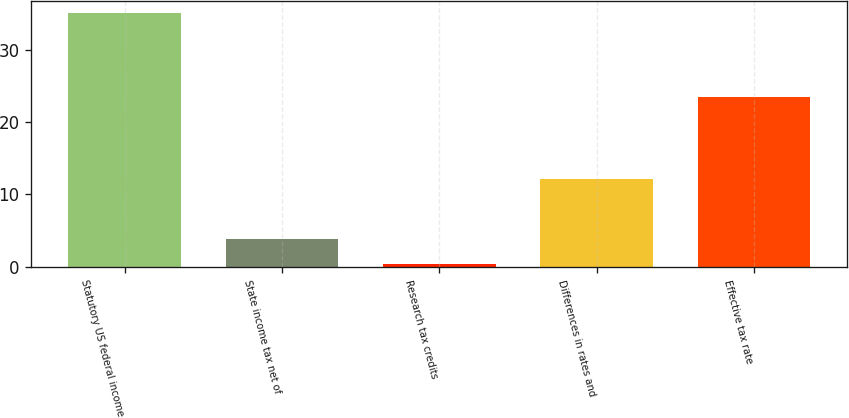Convert chart to OTSL. <chart><loc_0><loc_0><loc_500><loc_500><bar_chart><fcel>Statutory US federal income<fcel>State income tax net of<fcel>Research tax credits<fcel>Differences in rates and<fcel>Effective tax rate<nl><fcel>35<fcel>3.86<fcel>0.4<fcel>12.1<fcel>23.5<nl></chart> 